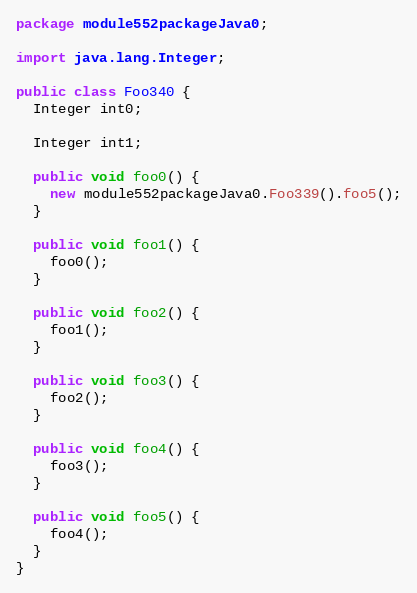<code> <loc_0><loc_0><loc_500><loc_500><_Java_>package module552packageJava0;

import java.lang.Integer;

public class Foo340 {
  Integer int0;

  Integer int1;

  public void foo0() {
    new module552packageJava0.Foo339().foo5();
  }

  public void foo1() {
    foo0();
  }

  public void foo2() {
    foo1();
  }

  public void foo3() {
    foo2();
  }

  public void foo4() {
    foo3();
  }

  public void foo5() {
    foo4();
  }
}
</code> 